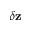Convert formula to latex. <formula><loc_0><loc_0><loc_500><loc_500>\delta z</formula> 